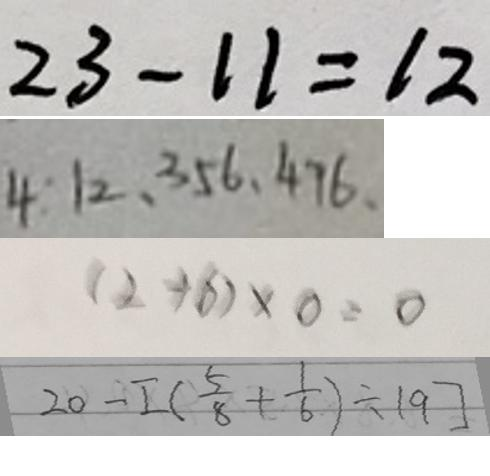Convert formula to latex. <formula><loc_0><loc_0><loc_500><loc_500>2 3 - 1 1 = 1 2 
 4 : 1 2 , 3 5 6 , 4 7 6 , 
 ( 2 + 6 ) \times 0 = 0 
 2 0 - [ ( \frac { 5 } { 8 } + \frac { 1 } { 6 } ) \div 1 9 ]</formula> 